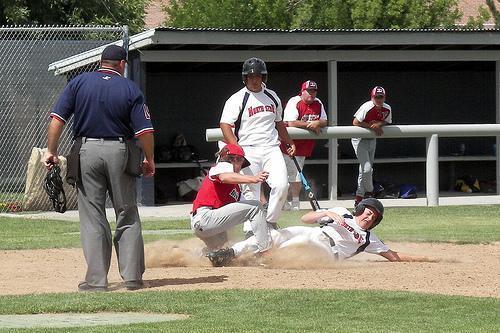How many players are holding a bat?
Give a very brief answer. 1. 